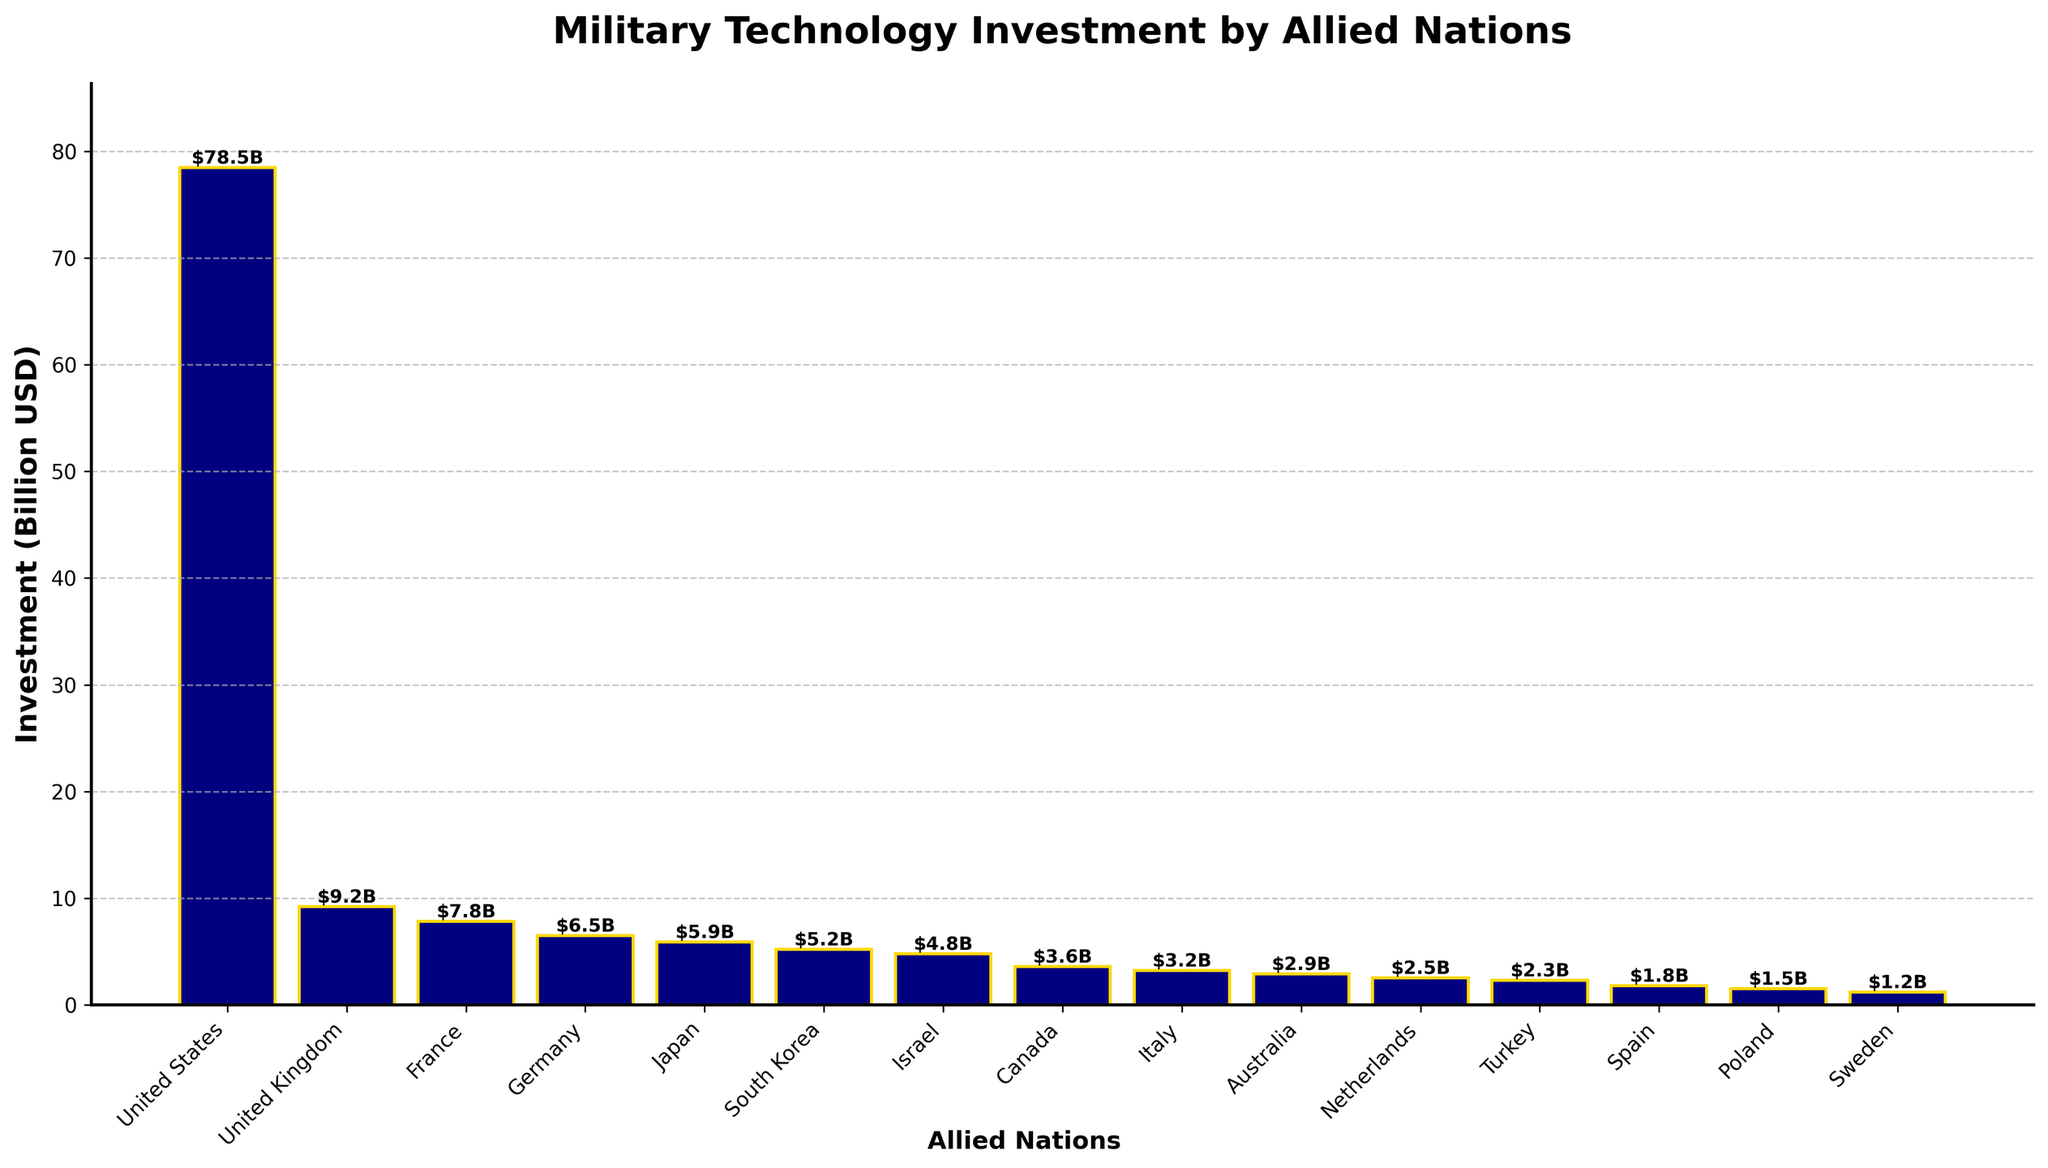What is the military technology investment of the United States? To find the military technology investment of the United States, look at the bar corresponding to the United States and read the height which represents the investment.
Answer: 78.5 billion USD Which country has the lowest investment in military technology? Compare the heights of all the bars; the shortest bar represents the country with the lowest investment. The bar for Sweden is the shortest.
Answer: Sweden How much more does the United States invest compared to Germany? Subtract Germany's investment from the United States' investment. The US invests 78.5 billion USD and Germany invests 6.5 billion USD, so the difference is 78.5 - 6.5.
Answer: 72 billion USD Which countries have an investment greater than 5 billion USD but less than 10 billion USD? Look at the bars whose heights fall between 5 and 10 billion USD. These countries are Japan, South Korea, Israel, and the United Kingdom.
Answer: Japan, South Korea, Israel, United Kingdom What is the combined military technology investment of France, Germany, and Italy? Add the investments of the three countries: France (7.8 billion USD), Germany (6.5 billion USD), and Italy (3.2 billion USD). The total is 7.8 + 6.5 + 3.2.
Answer: 17.5 billion USD Which three countries are in the middle range of investments? Arrange the countries by investment values and pick the three countries in the middle: South Korea (5.2), Israel (4.8), and Canada (3.6).
Answer: South Korea, Israel, Canada What is the average investment of the top three investing countries? Add the investments of the top three countries (United States, United Kingdom, France) and divide by three. (78.5 + 9.2 + 7.8) / 3.
Answer: 31.83 billion USD How many countries have an investment lower than 3 billion USD? Count the number of bars whose heights are below 3 billion USD. These countries are Italy, Australia, Netherlands, Turkey, Spain, Poland, and Sweden.
Answer: 7 What is the ratio of military investment between the highest and lowest investing countries? Divide the investment of the highest investing country (United States) by the investment of the lowest (Sweden). 78.5 / 1.2.
Answer: 65.42 Which visual attribute makes the investments easier to compare in the bar chart? The height of the bars is the primary visual attribute reflecting the different amounts of military technology investment, making it easier to compare.
Answer: Height of the bars 